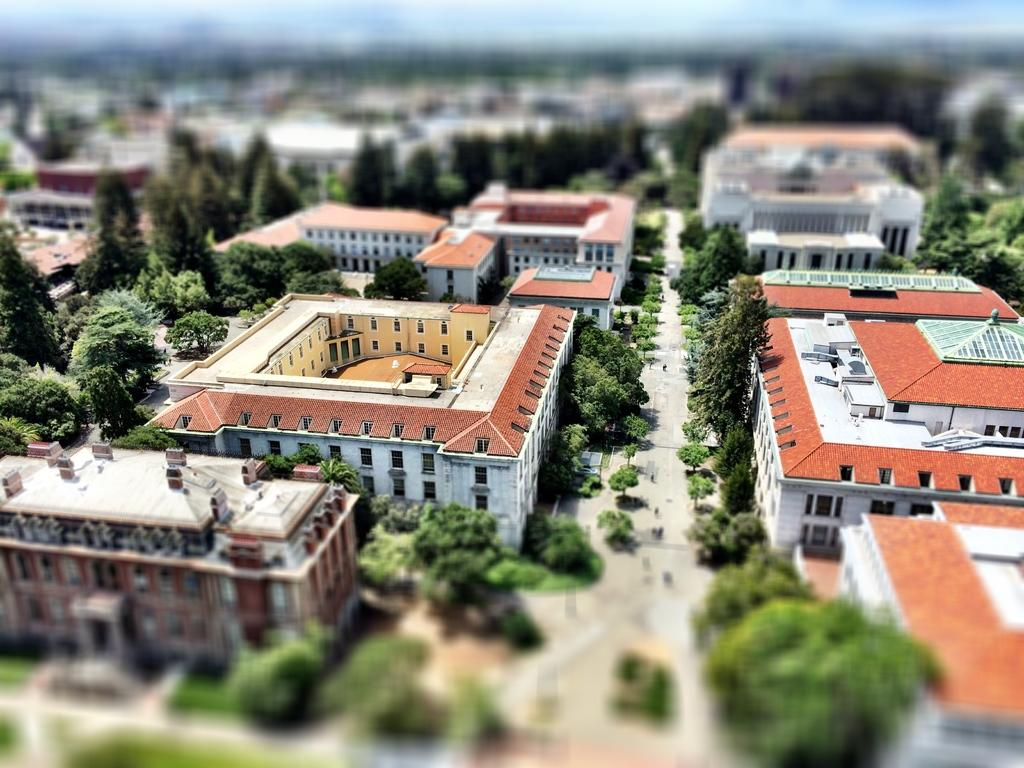What type of structures can be seen in the image? There are buildings in the image. What natural elements are present in the image? There are trees and plants in the image. What man-made feature is visible in the image? There is a road in the image. What part of the image appears blurry? The bottom part of the image appears blurry. What is visible at the top of the image? The sky is visible at the top of the image. Where is the tub located in the image? There is no tub present in the image. How can you help the plants grow in the image? The image does not depict a scenario where you can directly help the plants grow. 